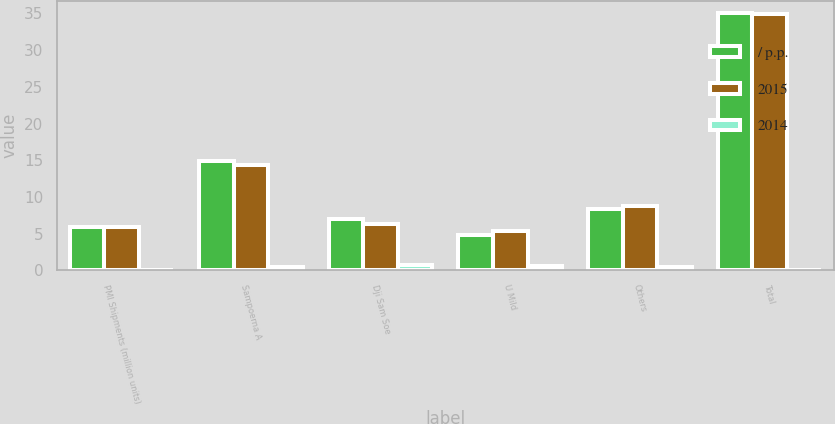Convert chart to OTSL. <chart><loc_0><loc_0><loc_500><loc_500><stacked_bar_chart><ecel><fcel>PMI Shipments (million units)<fcel>Sampoerna A<fcel>Dji Sam Soe<fcel>U Mild<fcel>Others<fcel>Total<nl><fcel>/ p.p.<fcel>5.85<fcel>14.9<fcel>7<fcel>4.8<fcel>8.3<fcel>35<nl><fcel>2015<fcel>5.85<fcel>14.4<fcel>6.3<fcel>5.4<fcel>8.8<fcel>34.9<nl><fcel>2014<fcel>0.1<fcel>0.5<fcel>0.7<fcel>0.6<fcel>0.5<fcel>0.1<nl></chart> 